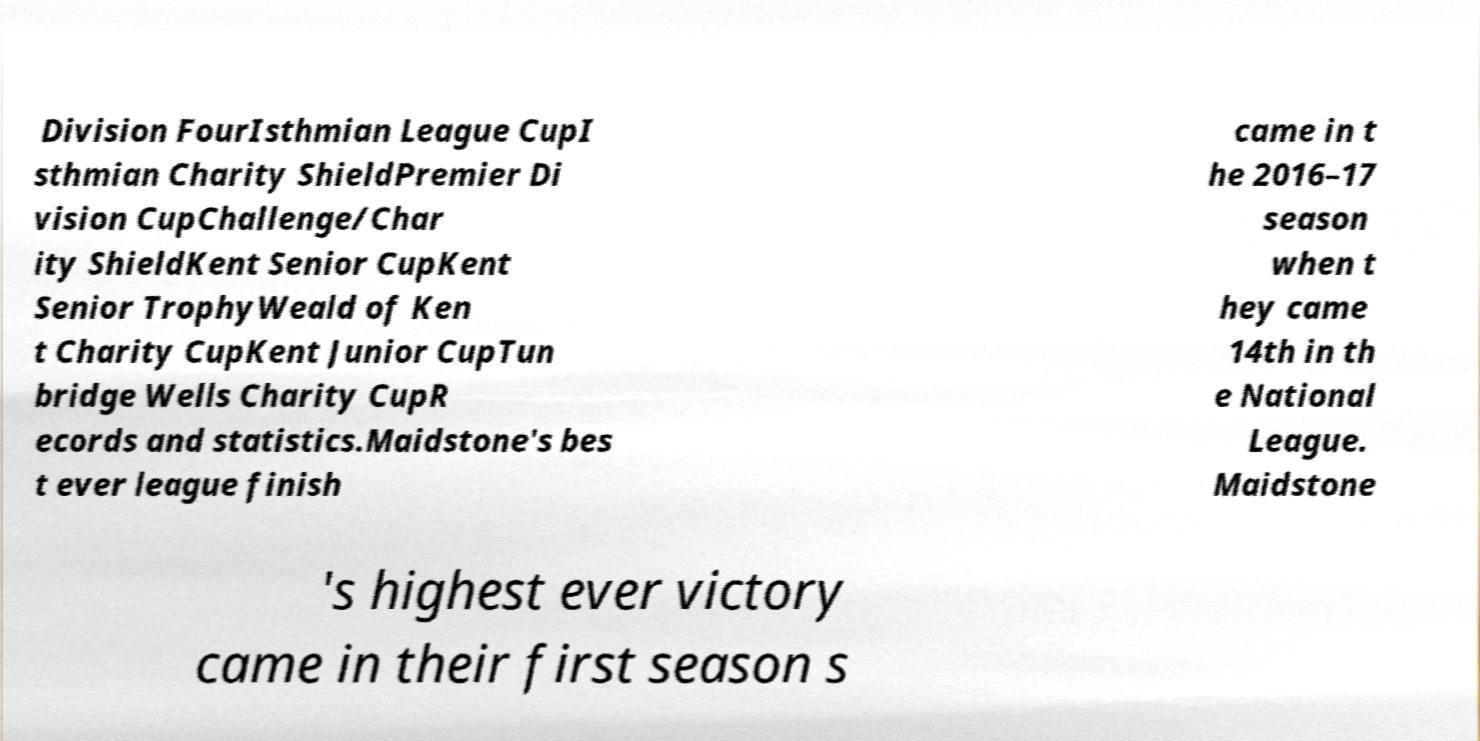What messages or text are displayed in this image? I need them in a readable, typed format. Division FourIsthmian League CupI sthmian Charity ShieldPremier Di vision CupChallenge/Char ity ShieldKent Senior CupKent Senior TrophyWeald of Ken t Charity CupKent Junior CupTun bridge Wells Charity CupR ecords and statistics.Maidstone's bes t ever league finish came in t he 2016–17 season when t hey came 14th in th e National League. Maidstone 's highest ever victory came in their first season s 